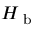Convert formula to latex. <formula><loc_0><loc_0><loc_500><loc_500>H _ { b }</formula> 